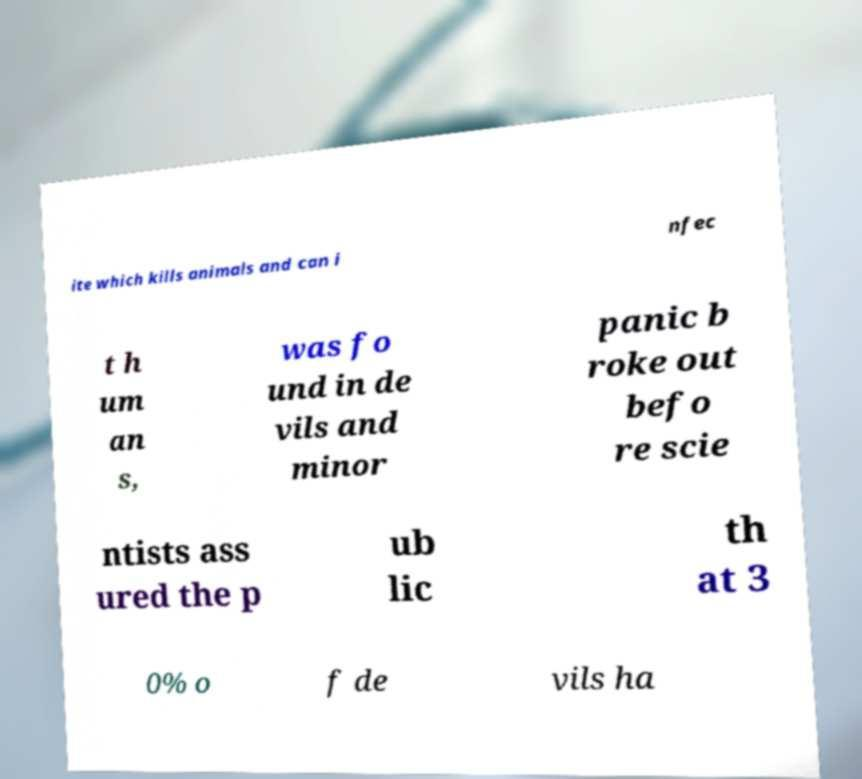Could you extract and type out the text from this image? ite which kills animals and can i nfec t h um an s, was fo und in de vils and minor panic b roke out befo re scie ntists ass ured the p ub lic th at 3 0% o f de vils ha 